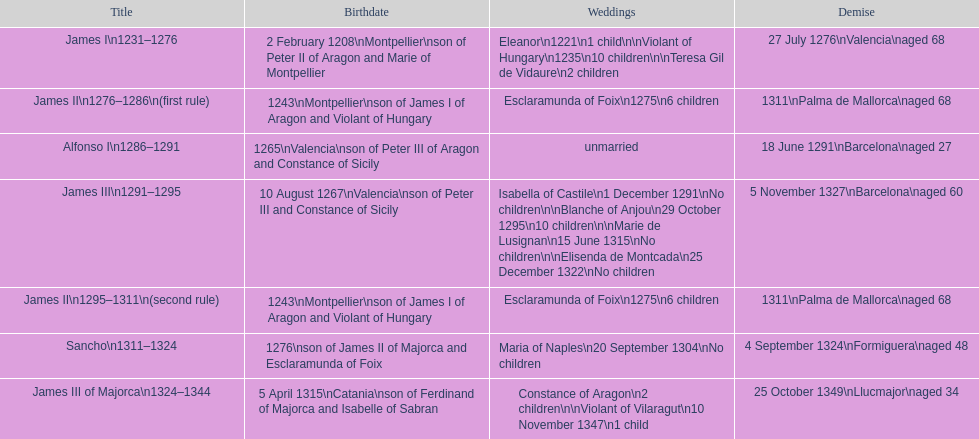Which monarch had the most marriages? James III 1291-1295. 